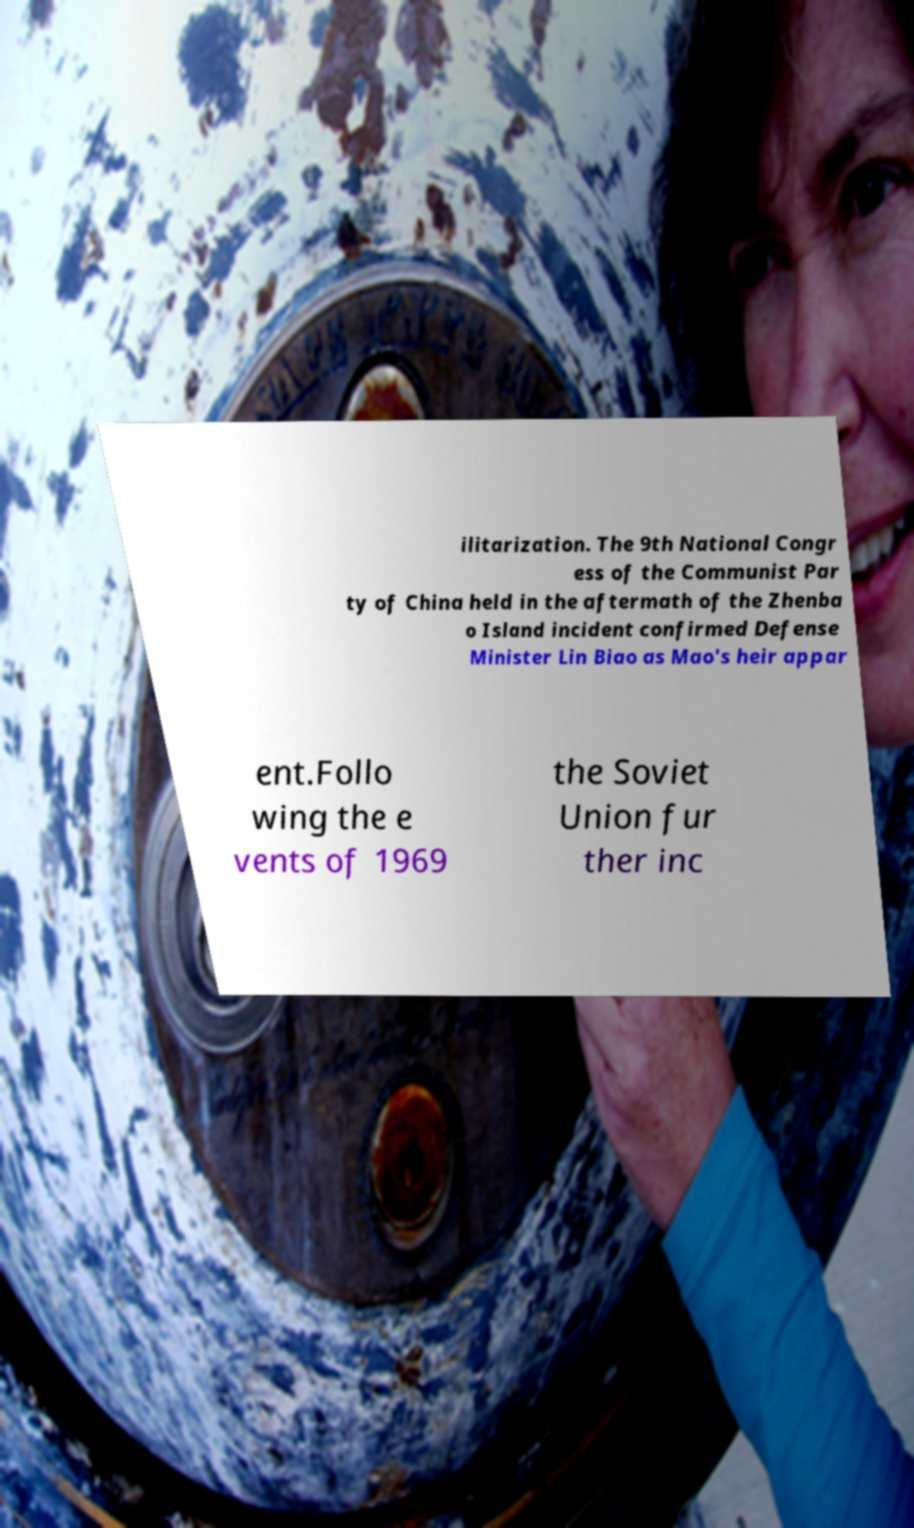What messages or text are displayed in this image? I need them in a readable, typed format. ilitarization. The 9th National Congr ess of the Communist Par ty of China held in the aftermath of the Zhenba o Island incident confirmed Defense Minister Lin Biao as Mao's heir appar ent.Follo wing the e vents of 1969 the Soviet Union fur ther inc 